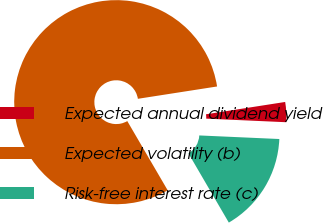Convert chart. <chart><loc_0><loc_0><loc_500><loc_500><pie_chart><fcel>Expected annual dividend yield<fcel>Expected volatility (b)<fcel>Risk-free interest rate (c)<nl><fcel>3.17%<fcel>80.95%<fcel>15.88%<nl></chart> 